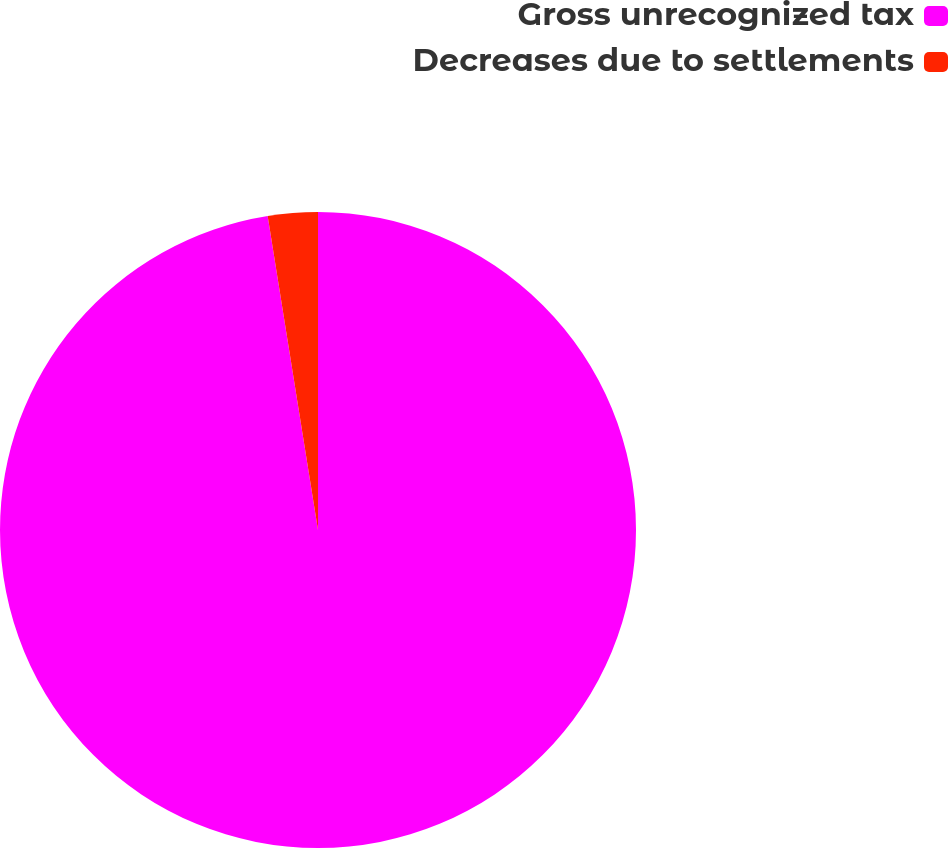<chart> <loc_0><loc_0><loc_500><loc_500><pie_chart><fcel>Gross unrecognized tax<fcel>Decreases due to settlements<nl><fcel>97.47%<fcel>2.53%<nl></chart> 